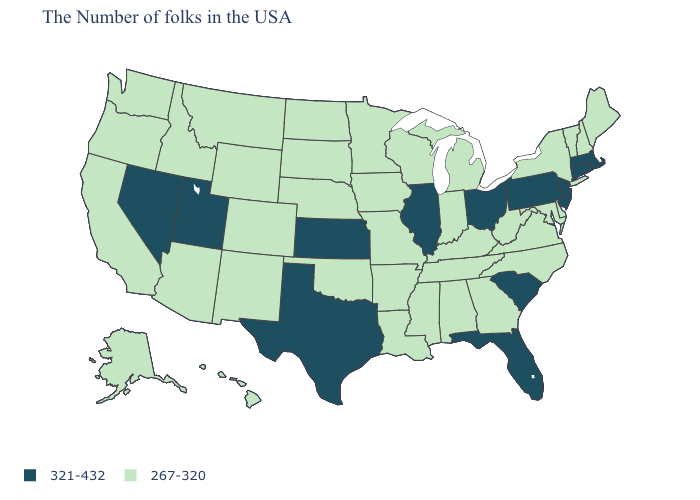Name the states that have a value in the range 321-432?
Keep it brief. Massachusetts, Rhode Island, Connecticut, New Jersey, Pennsylvania, South Carolina, Ohio, Florida, Illinois, Kansas, Texas, Utah, Nevada. Name the states that have a value in the range 321-432?
Write a very short answer. Massachusetts, Rhode Island, Connecticut, New Jersey, Pennsylvania, South Carolina, Ohio, Florida, Illinois, Kansas, Texas, Utah, Nevada. Among the states that border Texas , which have the lowest value?
Short answer required. Louisiana, Arkansas, Oklahoma, New Mexico. How many symbols are there in the legend?
Be succinct. 2. How many symbols are there in the legend?
Short answer required. 2. What is the value of Pennsylvania?
Concise answer only. 321-432. Does Kentucky have the same value as Pennsylvania?
Short answer required. No. What is the value of Florida?
Be succinct. 321-432. Among the states that border Washington , which have the lowest value?
Be succinct. Idaho, Oregon. How many symbols are there in the legend?
Give a very brief answer. 2. What is the value of Alaska?
Be succinct. 267-320. Is the legend a continuous bar?
Write a very short answer. No. What is the value of Wyoming?
Write a very short answer. 267-320. What is the value of Oregon?
Quick response, please. 267-320. Name the states that have a value in the range 267-320?
Be succinct. Maine, New Hampshire, Vermont, New York, Delaware, Maryland, Virginia, North Carolina, West Virginia, Georgia, Michigan, Kentucky, Indiana, Alabama, Tennessee, Wisconsin, Mississippi, Louisiana, Missouri, Arkansas, Minnesota, Iowa, Nebraska, Oklahoma, South Dakota, North Dakota, Wyoming, Colorado, New Mexico, Montana, Arizona, Idaho, California, Washington, Oregon, Alaska, Hawaii. 